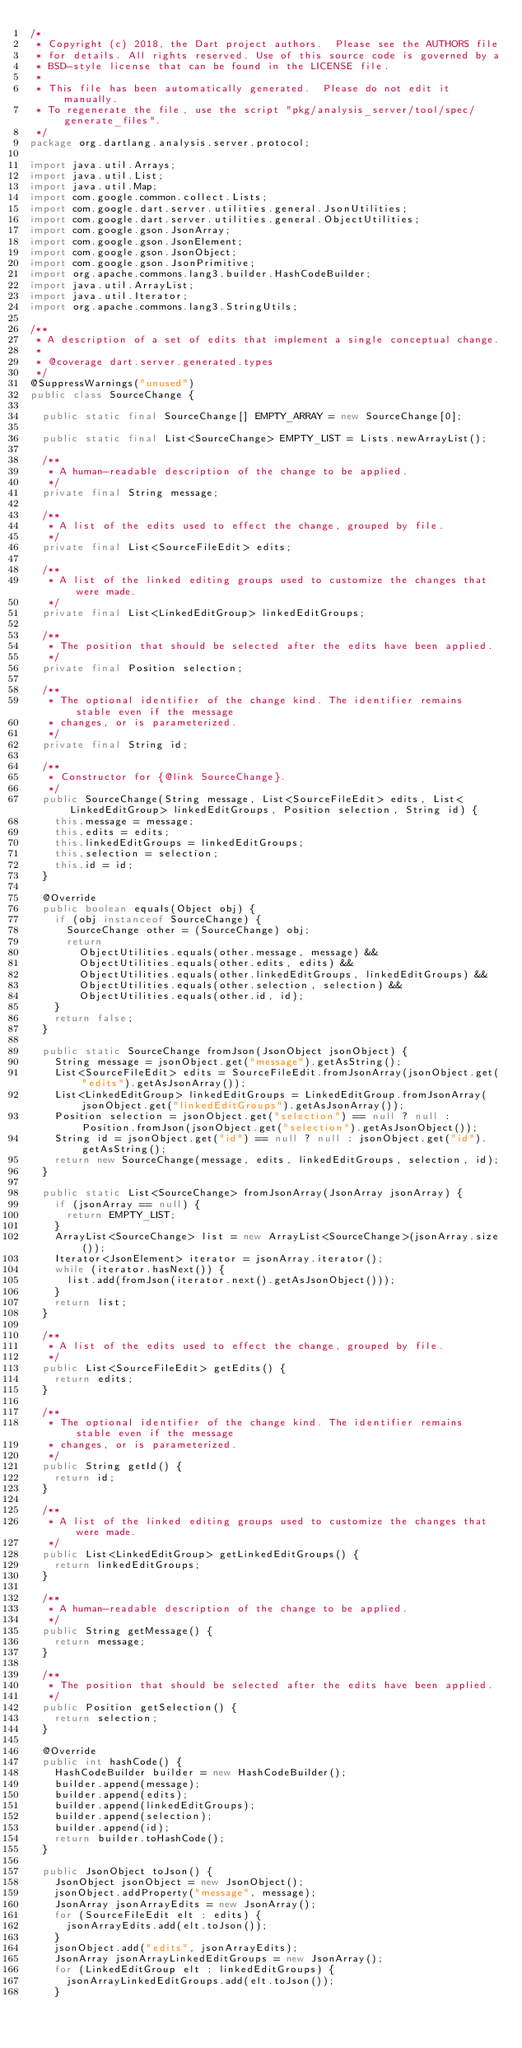Convert code to text. <code><loc_0><loc_0><loc_500><loc_500><_Java_>/*
 * Copyright (c) 2018, the Dart project authors.  Please see the AUTHORS file
 * for details. All rights reserved. Use of this source code is governed by a
 * BSD-style license that can be found in the LICENSE file.
 *
 * This file has been automatically generated.  Please do not edit it manually.
 * To regenerate the file, use the script "pkg/analysis_server/tool/spec/generate_files".
 */
package org.dartlang.analysis.server.protocol;

import java.util.Arrays;
import java.util.List;
import java.util.Map;
import com.google.common.collect.Lists;
import com.google.dart.server.utilities.general.JsonUtilities;
import com.google.dart.server.utilities.general.ObjectUtilities;
import com.google.gson.JsonArray;
import com.google.gson.JsonElement;
import com.google.gson.JsonObject;
import com.google.gson.JsonPrimitive;
import org.apache.commons.lang3.builder.HashCodeBuilder;
import java.util.ArrayList;
import java.util.Iterator;
import org.apache.commons.lang3.StringUtils;

/**
 * A description of a set of edits that implement a single conceptual change.
 *
 * @coverage dart.server.generated.types
 */
@SuppressWarnings("unused")
public class SourceChange {

  public static final SourceChange[] EMPTY_ARRAY = new SourceChange[0];

  public static final List<SourceChange> EMPTY_LIST = Lists.newArrayList();

  /**
   * A human-readable description of the change to be applied.
   */
  private final String message;

  /**
   * A list of the edits used to effect the change, grouped by file.
   */
  private final List<SourceFileEdit> edits;

  /**
   * A list of the linked editing groups used to customize the changes that were made.
   */
  private final List<LinkedEditGroup> linkedEditGroups;

  /**
   * The position that should be selected after the edits have been applied.
   */
  private final Position selection;

  /**
   * The optional identifier of the change kind. The identifier remains stable even if the message
   * changes, or is parameterized.
   */
  private final String id;

  /**
   * Constructor for {@link SourceChange}.
   */
  public SourceChange(String message, List<SourceFileEdit> edits, List<LinkedEditGroup> linkedEditGroups, Position selection, String id) {
    this.message = message;
    this.edits = edits;
    this.linkedEditGroups = linkedEditGroups;
    this.selection = selection;
    this.id = id;
  }

  @Override
  public boolean equals(Object obj) {
    if (obj instanceof SourceChange) {
      SourceChange other = (SourceChange) obj;
      return
        ObjectUtilities.equals(other.message, message) &&
        ObjectUtilities.equals(other.edits, edits) &&
        ObjectUtilities.equals(other.linkedEditGroups, linkedEditGroups) &&
        ObjectUtilities.equals(other.selection, selection) &&
        ObjectUtilities.equals(other.id, id);
    }
    return false;
  }

  public static SourceChange fromJson(JsonObject jsonObject) {
    String message = jsonObject.get("message").getAsString();
    List<SourceFileEdit> edits = SourceFileEdit.fromJsonArray(jsonObject.get("edits").getAsJsonArray());
    List<LinkedEditGroup> linkedEditGroups = LinkedEditGroup.fromJsonArray(jsonObject.get("linkedEditGroups").getAsJsonArray());
    Position selection = jsonObject.get("selection") == null ? null : Position.fromJson(jsonObject.get("selection").getAsJsonObject());
    String id = jsonObject.get("id") == null ? null : jsonObject.get("id").getAsString();
    return new SourceChange(message, edits, linkedEditGroups, selection, id);
  }

  public static List<SourceChange> fromJsonArray(JsonArray jsonArray) {
    if (jsonArray == null) {
      return EMPTY_LIST;
    }
    ArrayList<SourceChange> list = new ArrayList<SourceChange>(jsonArray.size());
    Iterator<JsonElement> iterator = jsonArray.iterator();
    while (iterator.hasNext()) {
      list.add(fromJson(iterator.next().getAsJsonObject()));
    }
    return list;
  }

  /**
   * A list of the edits used to effect the change, grouped by file.
   */
  public List<SourceFileEdit> getEdits() {
    return edits;
  }

  /**
   * The optional identifier of the change kind. The identifier remains stable even if the message
   * changes, or is parameterized.
   */
  public String getId() {
    return id;
  }

  /**
   * A list of the linked editing groups used to customize the changes that were made.
   */
  public List<LinkedEditGroup> getLinkedEditGroups() {
    return linkedEditGroups;
  }

  /**
   * A human-readable description of the change to be applied.
   */
  public String getMessage() {
    return message;
  }

  /**
   * The position that should be selected after the edits have been applied.
   */
  public Position getSelection() {
    return selection;
  }

  @Override
  public int hashCode() {
    HashCodeBuilder builder = new HashCodeBuilder();
    builder.append(message);
    builder.append(edits);
    builder.append(linkedEditGroups);
    builder.append(selection);
    builder.append(id);
    return builder.toHashCode();
  }

  public JsonObject toJson() {
    JsonObject jsonObject = new JsonObject();
    jsonObject.addProperty("message", message);
    JsonArray jsonArrayEdits = new JsonArray();
    for (SourceFileEdit elt : edits) {
      jsonArrayEdits.add(elt.toJson());
    }
    jsonObject.add("edits", jsonArrayEdits);
    JsonArray jsonArrayLinkedEditGroups = new JsonArray();
    for (LinkedEditGroup elt : linkedEditGroups) {
      jsonArrayLinkedEditGroups.add(elt.toJson());
    }</code> 